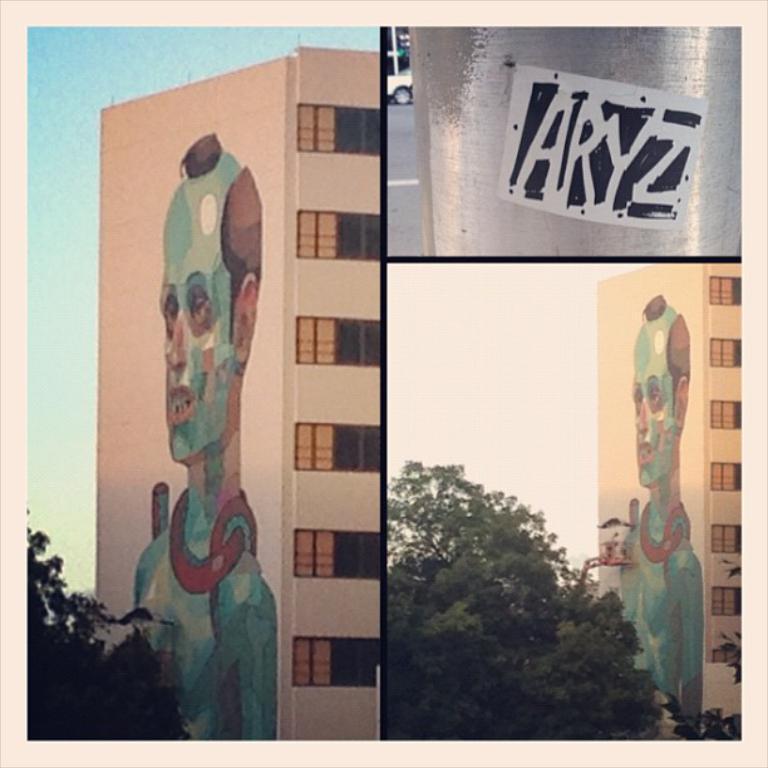How would you summarize this image in a sentence or two? This is a collage. On the left side image there is a building with windows and a painting of a person. Also there is a tree. On the top right corner there is a image with something written on that. Below the image there is a building with windows and a painting of a person. Also there is a tree. 